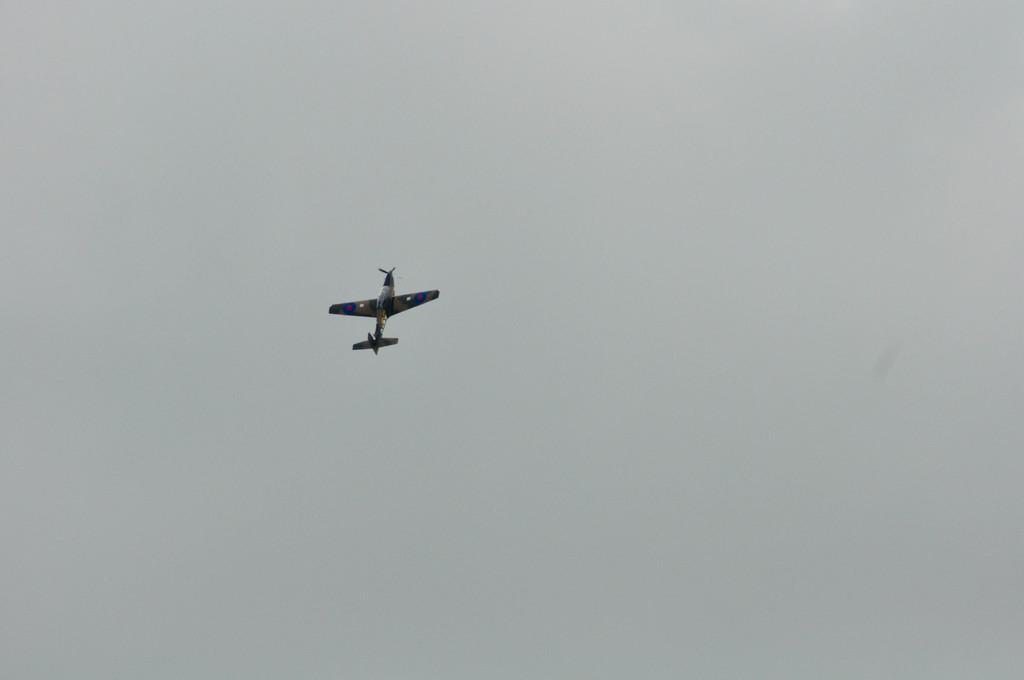Describe this image in one or two sentences. In this image I can see an aircraft which is yellow, blue and black in color is flying in the air and I can see the sky in the background. 